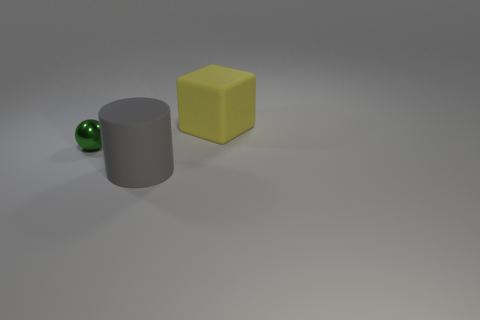Are any big green shiny cylinders visible?
Your answer should be very brief. No. Are there more yellow cubes to the right of the green metal object than small metallic spheres that are to the right of the gray matte thing?
Make the answer very short. Yes. Are there any other things that have the same size as the shiny thing?
Give a very brief answer. No. What shape is the tiny shiny thing?
Offer a terse response. Sphere. Is the number of rubber objects that are behind the gray cylinder greater than the number of large cyan shiny objects?
Give a very brief answer. Yes. There is a rubber object that is behind the cylinder; what is its shape?
Your answer should be compact. Cube. How many other objects are there of the same shape as the tiny green shiny object?
Provide a short and direct response. 0. Is the material of the big thing that is on the left side of the yellow object the same as the yellow cube?
Your answer should be very brief. Yes. Is the number of small metal objects that are behind the gray cylinder the same as the number of large matte cylinders that are right of the green shiny object?
Make the answer very short. Yes. What is the size of the object that is to the right of the big matte cylinder?
Make the answer very short. Large. 